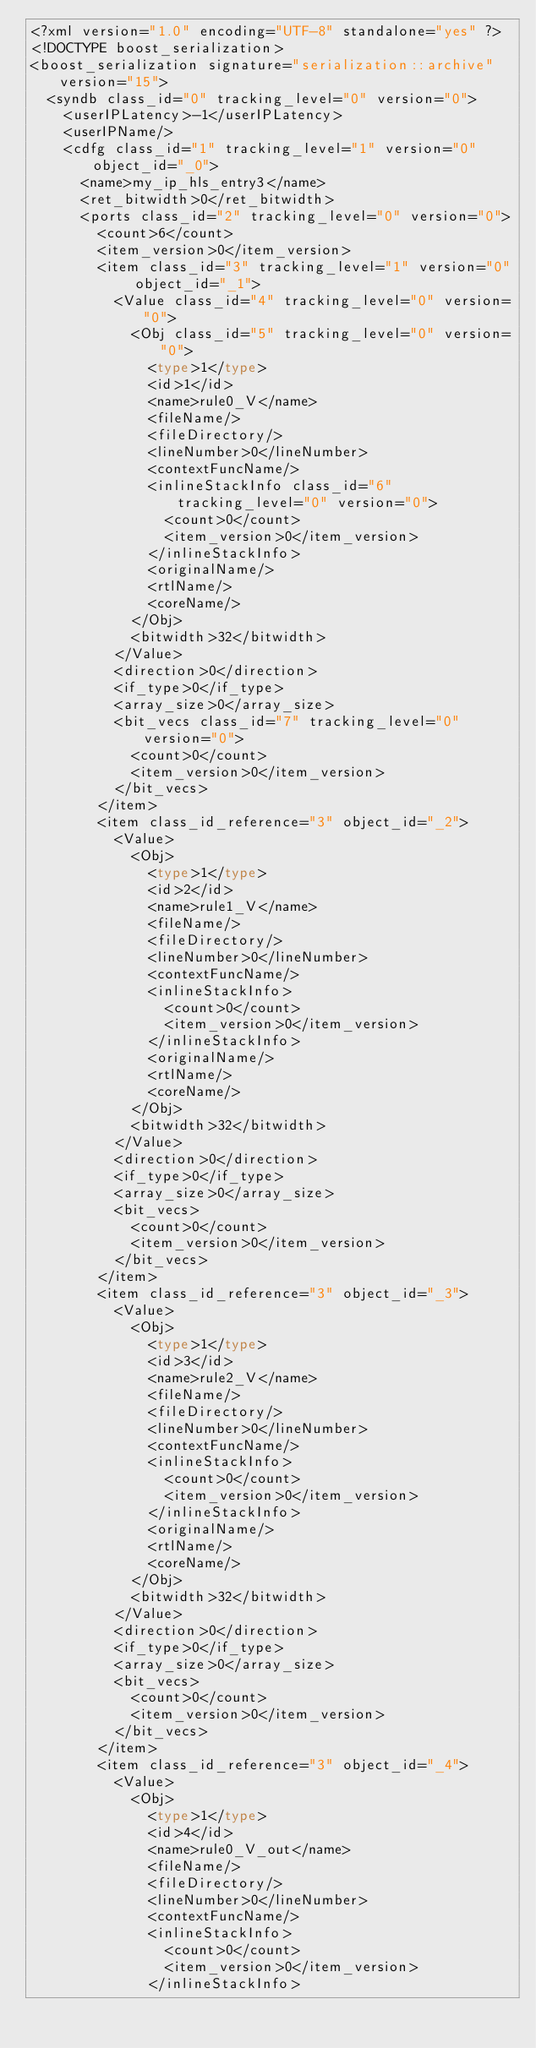<code> <loc_0><loc_0><loc_500><loc_500><_Ada_><?xml version="1.0" encoding="UTF-8" standalone="yes" ?>
<!DOCTYPE boost_serialization>
<boost_serialization signature="serialization::archive" version="15">
  <syndb class_id="0" tracking_level="0" version="0">
    <userIPLatency>-1</userIPLatency>
    <userIPName/>
    <cdfg class_id="1" tracking_level="1" version="0" object_id="_0">
      <name>my_ip_hls_entry3</name>
      <ret_bitwidth>0</ret_bitwidth>
      <ports class_id="2" tracking_level="0" version="0">
        <count>6</count>
        <item_version>0</item_version>
        <item class_id="3" tracking_level="1" version="0" object_id="_1">
          <Value class_id="4" tracking_level="0" version="0">
            <Obj class_id="5" tracking_level="0" version="0">
              <type>1</type>
              <id>1</id>
              <name>rule0_V</name>
              <fileName/>
              <fileDirectory/>
              <lineNumber>0</lineNumber>
              <contextFuncName/>
              <inlineStackInfo class_id="6" tracking_level="0" version="0">
                <count>0</count>
                <item_version>0</item_version>
              </inlineStackInfo>
              <originalName/>
              <rtlName/>
              <coreName/>
            </Obj>
            <bitwidth>32</bitwidth>
          </Value>
          <direction>0</direction>
          <if_type>0</if_type>
          <array_size>0</array_size>
          <bit_vecs class_id="7" tracking_level="0" version="0">
            <count>0</count>
            <item_version>0</item_version>
          </bit_vecs>
        </item>
        <item class_id_reference="3" object_id="_2">
          <Value>
            <Obj>
              <type>1</type>
              <id>2</id>
              <name>rule1_V</name>
              <fileName/>
              <fileDirectory/>
              <lineNumber>0</lineNumber>
              <contextFuncName/>
              <inlineStackInfo>
                <count>0</count>
                <item_version>0</item_version>
              </inlineStackInfo>
              <originalName/>
              <rtlName/>
              <coreName/>
            </Obj>
            <bitwidth>32</bitwidth>
          </Value>
          <direction>0</direction>
          <if_type>0</if_type>
          <array_size>0</array_size>
          <bit_vecs>
            <count>0</count>
            <item_version>0</item_version>
          </bit_vecs>
        </item>
        <item class_id_reference="3" object_id="_3">
          <Value>
            <Obj>
              <type>1</type>
              <id>3</id>
              <name>rule2_V</name>
              <fileName/>
              <fileDirectory/>
              <lineNumber>0</lineNumber>
              <contextFuncName/>
              <inlineStackInfo>
                <count>0</count>
                <item_version>0</item_version>
              </inlineStackInfo>
              <originalName/>
              <rtlName/>
              <coreName/>
            </Obj>
            <bitwidth>32</bitwidth>
          </Value>
          <direction>0</direction>
          <if_type>0</if_type>
          <array_size>0</array_size>
          <bit_vecs>
            <count>0</count>
            <item_version>0</item_version>
          </bit_vecs>
        </item>
        <item class_id_reference="3" object_id="_4">
          <Value>
            <Obj>
              <type>1</type>
              <id>4</id>
              <name>rule0_V_out</name>
              <fileName/>
              <fileDirectory/>
              <lineNumber>0</lineNumber>
              <contextFuncName/>
              <inlineStackInfo>
                <count>0</count>
                <item_version>0</item_version>
              </inlineStackInfo></code> 